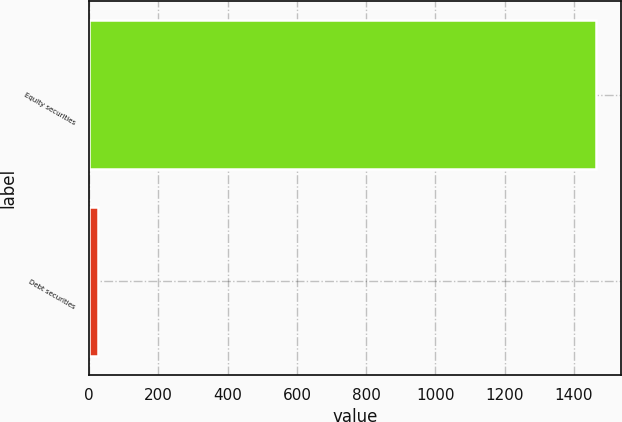<chart> <loc_0><loc_0><loc_500><loc_500><bar_chart><fcel>Equity securities<fcel>Debt securities<nl><fcel>1463<fcel>24<nl></chart> 